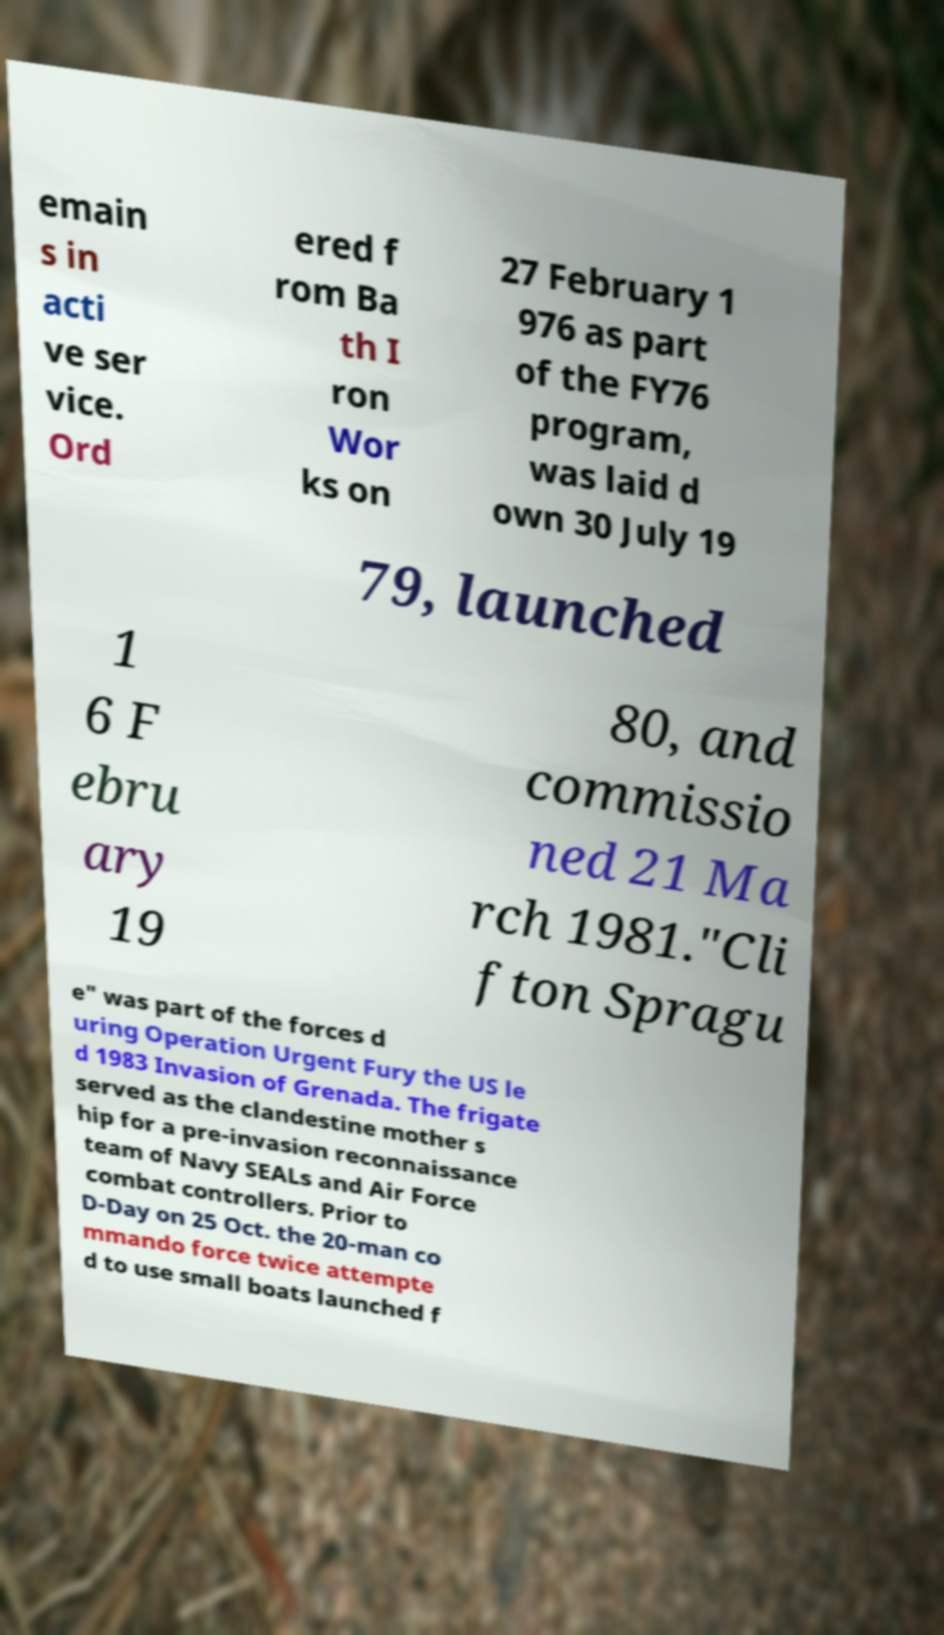I need the written content from this picture converted into text. Can you do that? emain s in acti ve ser vice. Ord ered f rom Ba th I ron Wor ks on 27 February 1 976 as part of the FY76 program, was laid d own 30 July 19 79, launched 1 6 F ebru ary 19 80, and commissio ned 21 Ma rch 1981."Cli fton Spragu e" was part of the forces d uring Operation Urgent Fury the US le d 1983 Invasion of Grenada. The frigate served as the clandestine mother s hip for a pre-invasion reconnaissance team of Navy SEALs and Air Force combat controllers. Prior to D-Day on 25 Oct. the 20-man co mmando force twice attempte d to use small boats launched f 